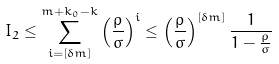Convert formula to latex. <formula><loc_0><loc_0><loc_500><loc_500>I _ { 2 } \leq \sum _ { i = \left [ \delta m \right ] } ^ { m + k _ { 0 } - k } \left ( \frac { \rho } { \sigma } \right ) ^ { i } \leq \left ( \frac { \rho } { \sigma } \right ) ^ { \left [ \delta m \right ] } \frac { 1 } { 1 - \frac { \rho } { \sigma } }</formula> 